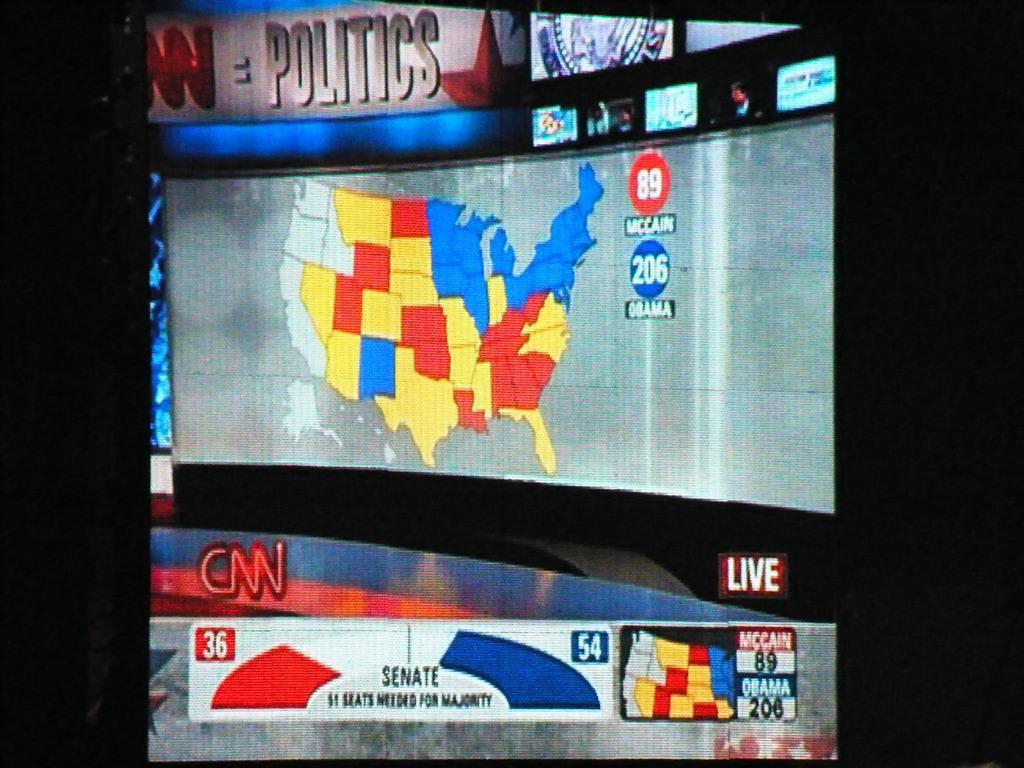<image>
Offer a succinct explanation of the picture presented. a screenshot from CNN about a Senate Politics New Jersey state map. 